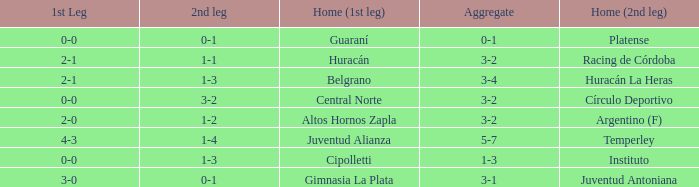What was the score of the 2nd leg when the Belgrano played the first leg at home with a score of 2-1? 1-3. 